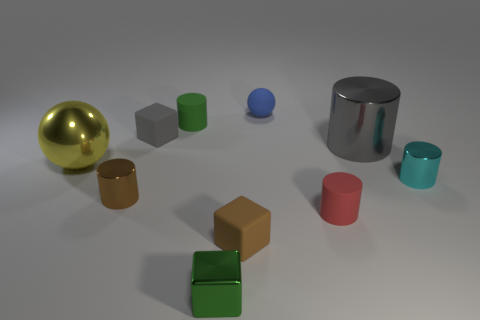There is a tiny thing that is on the right side of the big metal thing right of the big yellow shiny object; what color is it?
Ensure brevity in your answer.  Cyan. What is the color of the other matte thing that is the same shape as the tiny brown rubber thing?
Keep it short and to the point. Gray. Is there anything else that has the same material as the tiny blue ball?
Your response must be concise. Yes. The other metal thing that is the same shape as the tiny gray object is what size?
Your response must be concise. Small. There is a small cylinder to the right of the gray metallic cylinder; what is its material?
Offer a very short reply. Metal. Are there fewer cyan shiny cylinders to the left of the yellow object than large brown cylinders?
Keep it short and to the point. No. There is a yellow shiny object that is behind the small shiny object that is on the right side of the small red cylinder; what shape is it?
Provide a short and direct response. Sphere. What color is the small sphere?
Give a very brief answer. Blue. What number of other objects are the same size as the green metal object?
Keep it short and to the point. 7. What is the cylinder that is both in front of the small gray object and on the left side of the small metal cube made of?
Ensure brevity in your answer.  Metal. 